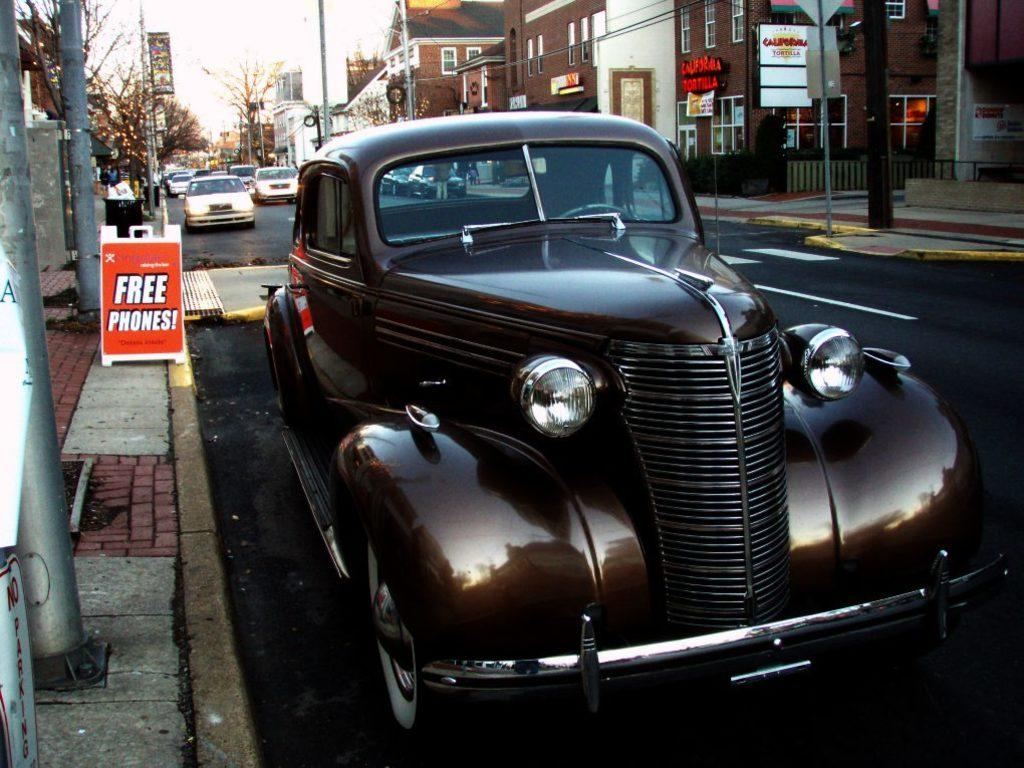<image>
Describe the image concisely. A classic car is parked on a city street next to a billboard for free phones. 